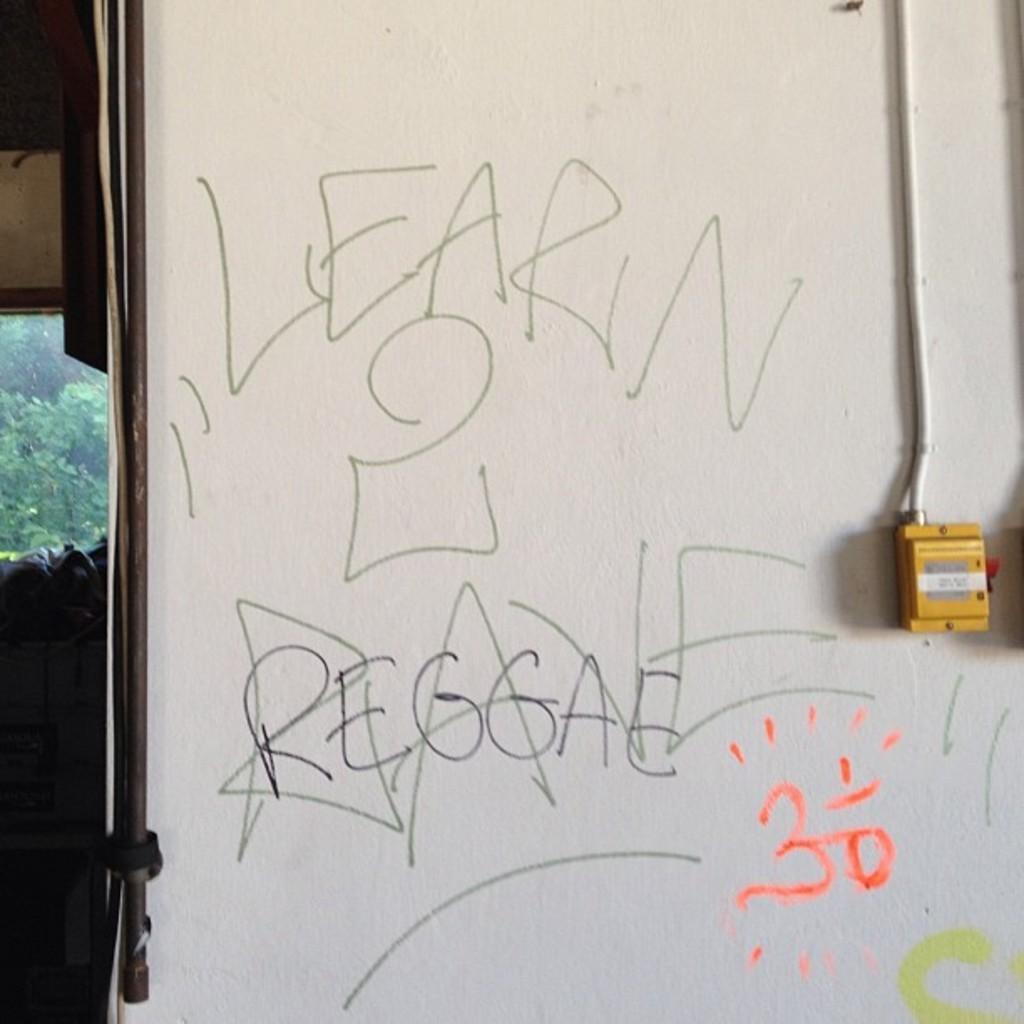Can you describe this image briefly? In the image there is a wall and on the wall there are some words and in the background there are trees. 